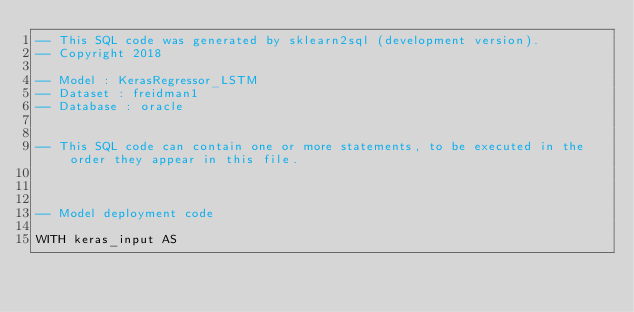<code> <loc_0><loc_0><loc_500><loc_500><_SQL_>-- This SQL code was generated by sklearn2sql (development version).
-- Copyright 2018

-- Model : KerasRegressor_LSTM
-- Dataset : freidman1
-- Database : oracle


-- This SQL code can contain one or more statements, to be executed in the order they appear in this file.



-- Model deployment code

WITH keras_input AS </code> 